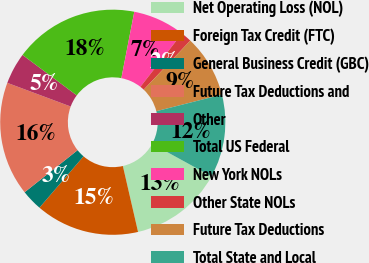<chart> <loc_0><loc_0><loc_500><loc_500><pie_chart><fcel>Net Operating Loss (NOL)<fcel>Foreign Tax Credit (FTC)<fcel>General Business Credit (GBC)<fcel>Future Tax Deductions and<fcel>Other<fcel>Total US Federal<fcel>New York NOLs<fcel>Other State NOLs<fcel>Future Tax Deductions<fcel>Total State and Local<nl><fcel>13.41%<fcel>14.89%<fcel>3.03%<fcel>16.37%<fcel>4.51%<fcel>17.86%<fcel>7.48%<fcel>1.55%<fcel>8.96%<fcel>11.93%<nl></chart> 